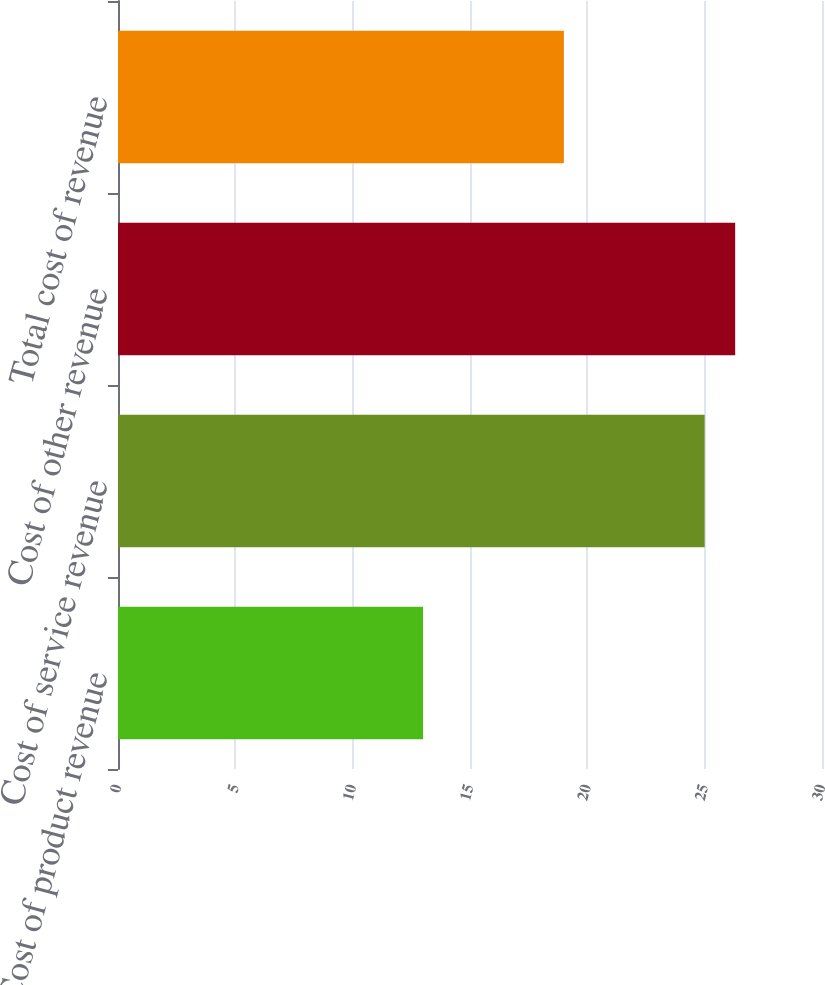Convert chart. <chart><loc_0><loc_0><loc_500><loc_500><bar_chart><fcel>Cost of product revenue<fcel>Cost of service revenue<fcel>Cost of other revenue<fcel>Total cost of revenue<nl><fcel>13<fcel>25<fcel>26.3<fcel>19<nl></chart> 